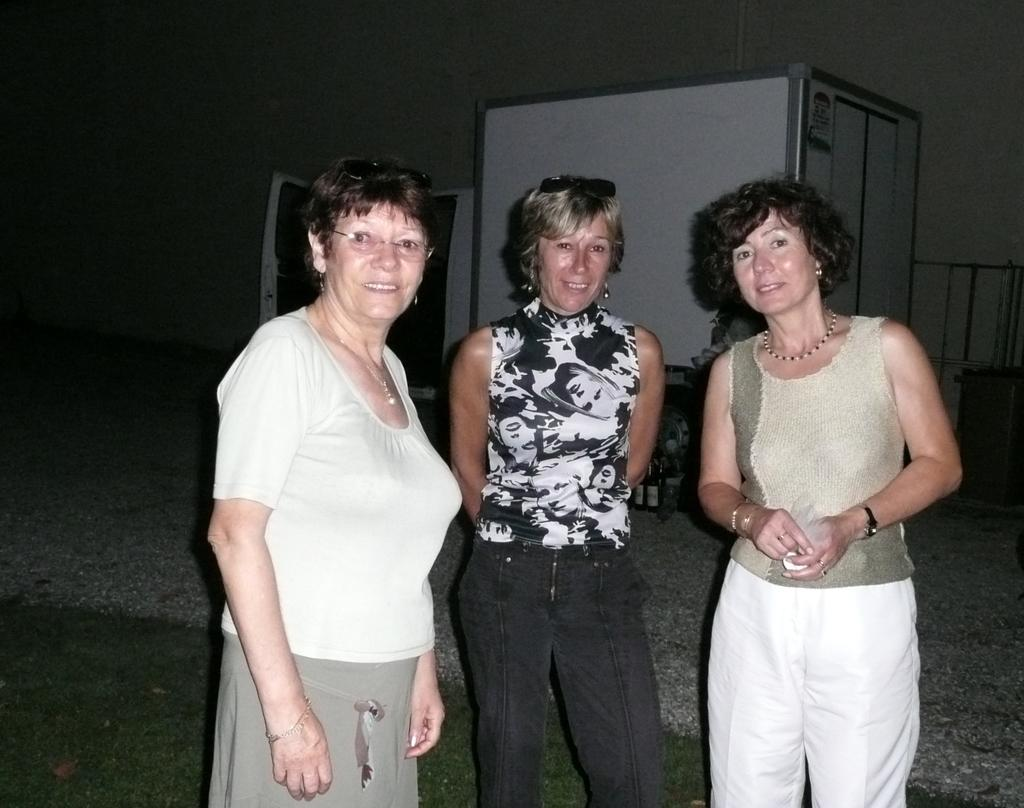How many people are in the image? There are three ladies in the image. What are the ladies doing in the image? The ladies are standing and smiling. What can be seen in the background of the image? There is a vehicle and a wall in the background of the image. What is visible at the bottom of the image? There is a road visible at the bottom of the image. What type of polish is the actor using on their shoes in the image? There is no actor or shoes present in the image, and therefore no polish can be observed. What is the shocking event happening in the image? There is no shocking event depicted in the image; it features three ladies standing and smiling. 